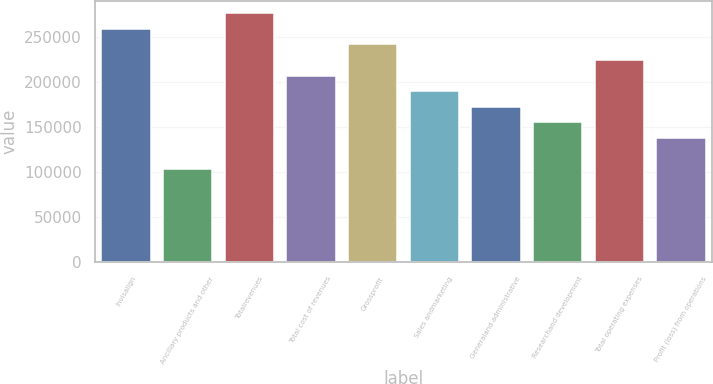Convert chart to OTSL. <chart><loc_0><loc_0><loc_500><loc_500><bar_chart><fcel>Invisalign<fcel>Ancillary products and other<fcel>Totalrevenues<fcel>Total cost of revenues<fcel>Grossprofit<fcel>Sales andmarketing<fcel>Generaland administrative<fcel>Researchand development<fcel>Total operating expenses<fcel>Profit (loss) from operations<nl><fcel>259245<fcel>103698<fcel>276528<fcel>207396<fcel>241962<fcel>190113<fcel>172830<fcel>155547<fcel>224679<fcel>138264<nl></chart> 